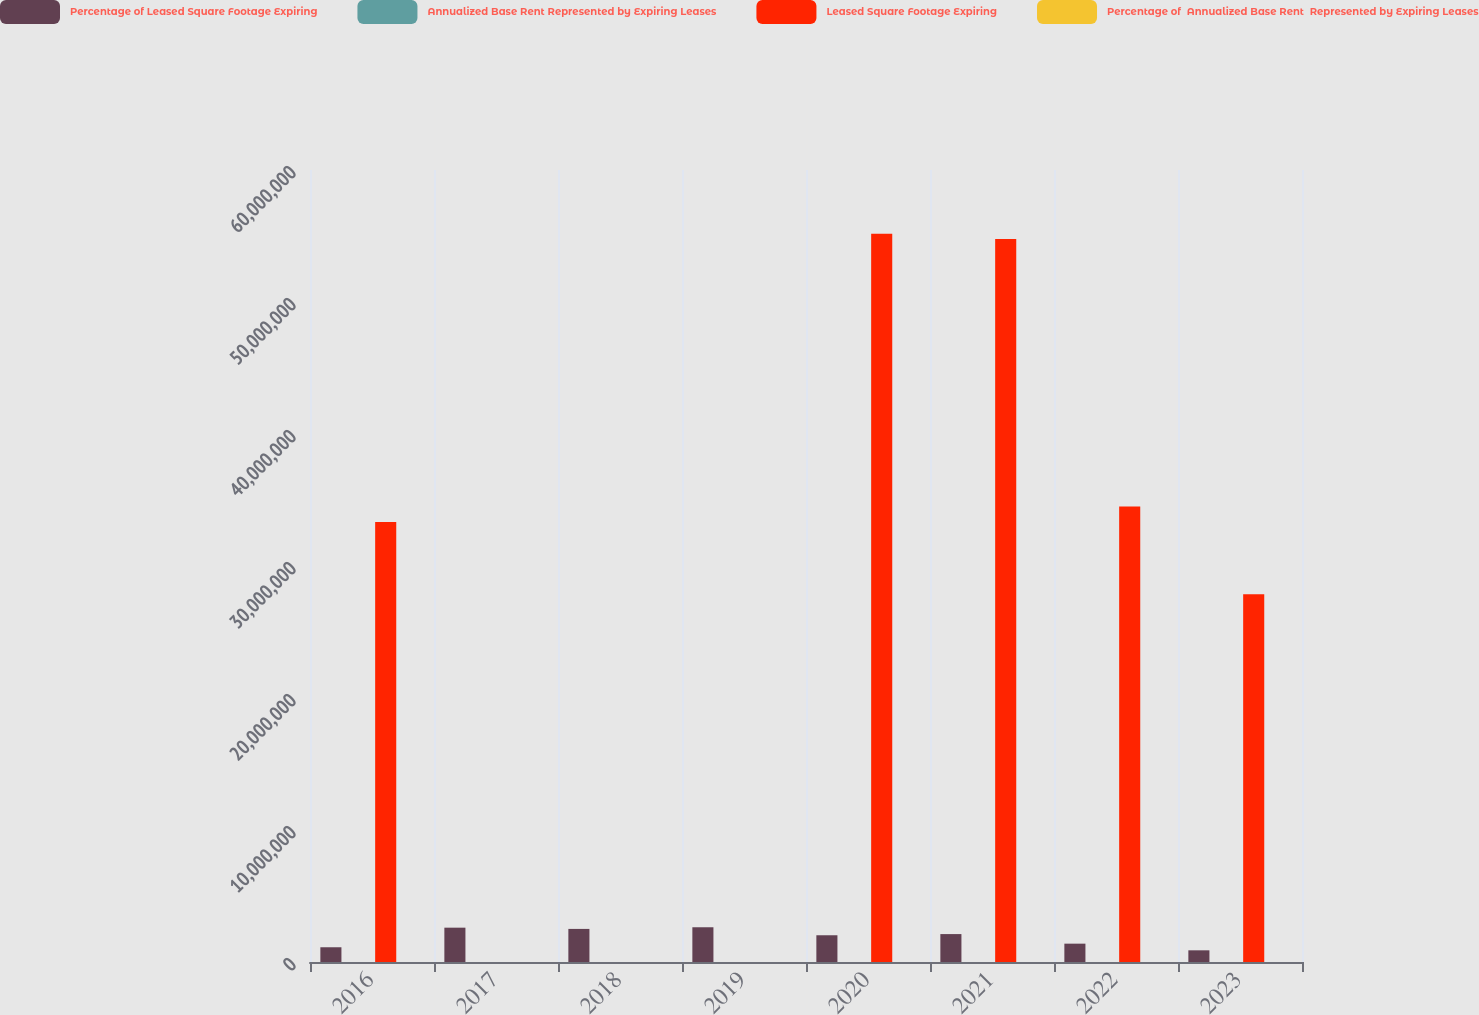Convert chart to OTSL. <chart><loc_0><loc_0><loc_500><loc_500><stacked_bar_chart><ecel><fcel>2016<fcel>2017<fcel>2018<fcel>2019<fcel>2020<fcel>2021<fcel>2022<fcel>2023<nl><fcel>Percentage of Leased Square Footage Expiring<fcel>1.117e+06<fcel>2.601e+06<fcel>2.507e+06<fcel>2.632e+06<fcel>2.026e+06<fcel>2.115e+06<fcel>1.39e+06<fcel>885000<nl><fcel>Annualized Base Rent Represented by Expiring Leases<fcel>6<fcel>13<fcel>13<fcel>13<fcel>10<fcel>11<fcel>7<fcel>4<nl><fcel>Leased Square Footage Expiring<fcel>3.3337e+07<fcel>13<fcel>13<fcel>13<fcel>5.5177e+07<fcel>5.4767e+07<fcel>3.4514e+07<fcel>2.7868e+07<nl><fcel>Percentage of  Annualized Base Rent  Represented by Expiring Leases<fcel>6<fcel>13<fcel>12<fcel>13<fcel>11<fcel>10<fcel>7<fcel>5<nl></chart> 